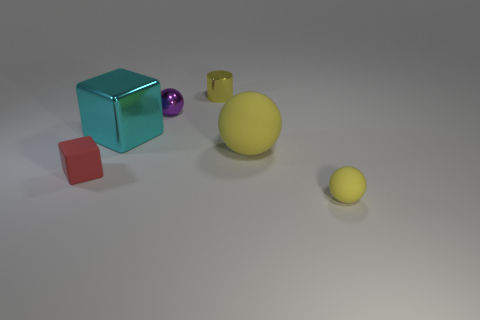There is a thing to the left of the large thing to the left of the small purple sphere; are there any spheres in front of it?
Give a very brief answer. Yes. Do the cylinder and the small thing to the left of the big metallic object have the same material?
Offer a very short reply. No. There is a ball behind the cube that is on the right side of the red object; what is its color?
Ensure brevity in your answer.  Purple. Is there a small matte thing that has the same color as the tiny metallic cylinder?
Make the answer very short. Yes. There is a metallic thing on the left side of the tiny purple sphere on the left side of the object in front of the small block; how big is it?
Offer a terse response. Large. Is the shape of the purple object the same as the tiny object that is in front of the rubber cube?
Your response must be concise. Yes. What number of other things are the same size as the matte block?
Make the answer very short. 3. What is the size of the shiny object that is to the left of the tiny shiny sphere?
Ensure brevity in your answer.  Large. What number of small red things have the same material as the large cyan thing?
Provide a succinct answer. 0. There is a yellow rubber object left of the tiny yellow rubber thing; is it the same shape as the tiny red thing?
Your answer should be compact. No. 